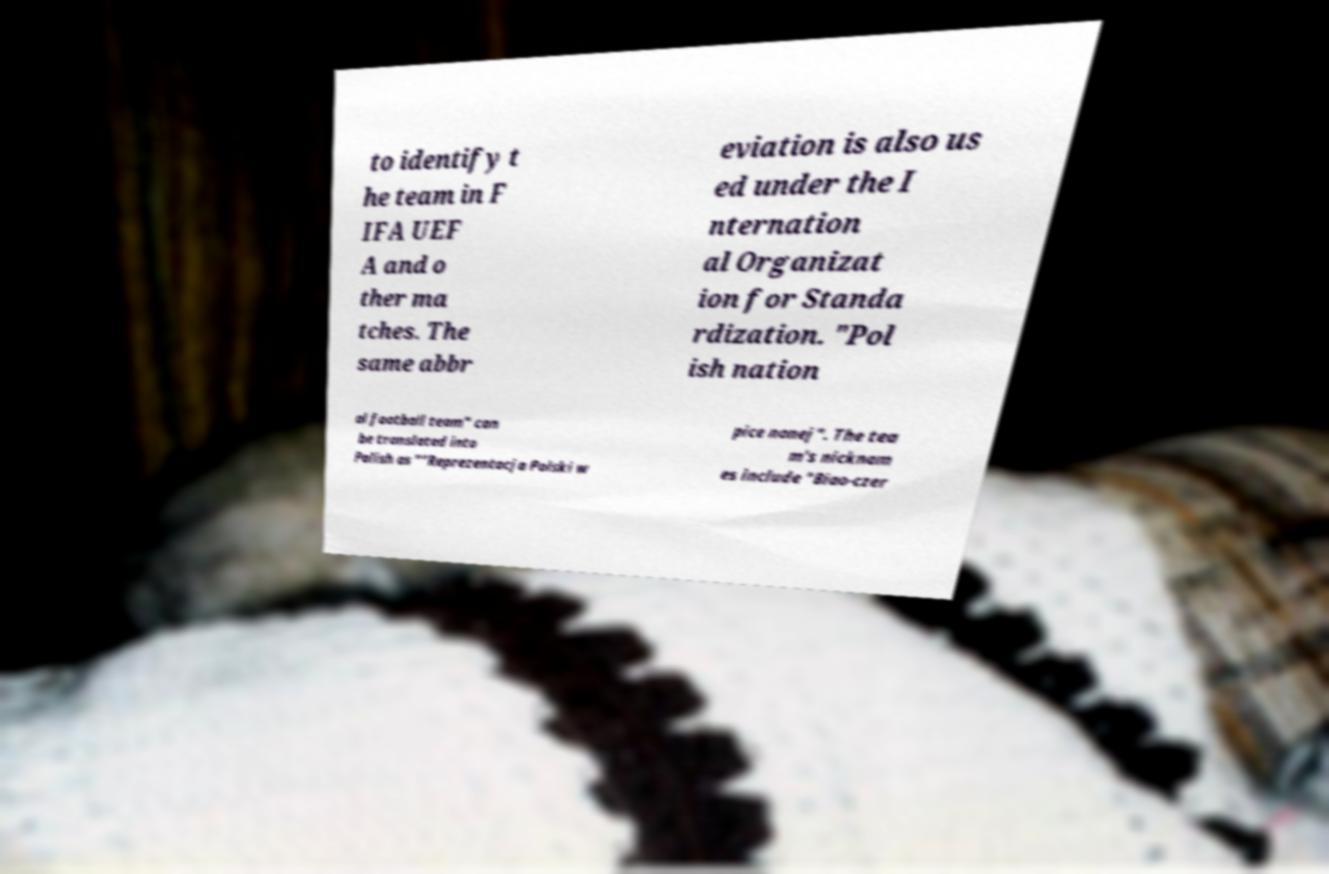Please read and relay the text visible in this image. What does it say? to identify t he team in F IFA UEF A and o ther ma tches. The same abbr eviation is also us ed under the I nternation al Organizat ion for Standa rdization. "Pol ish nation al football team" can be translated into Polish as ""Reprezentacja Polski w pice nonej". The tea m's nicknam es include "Biao-czer 